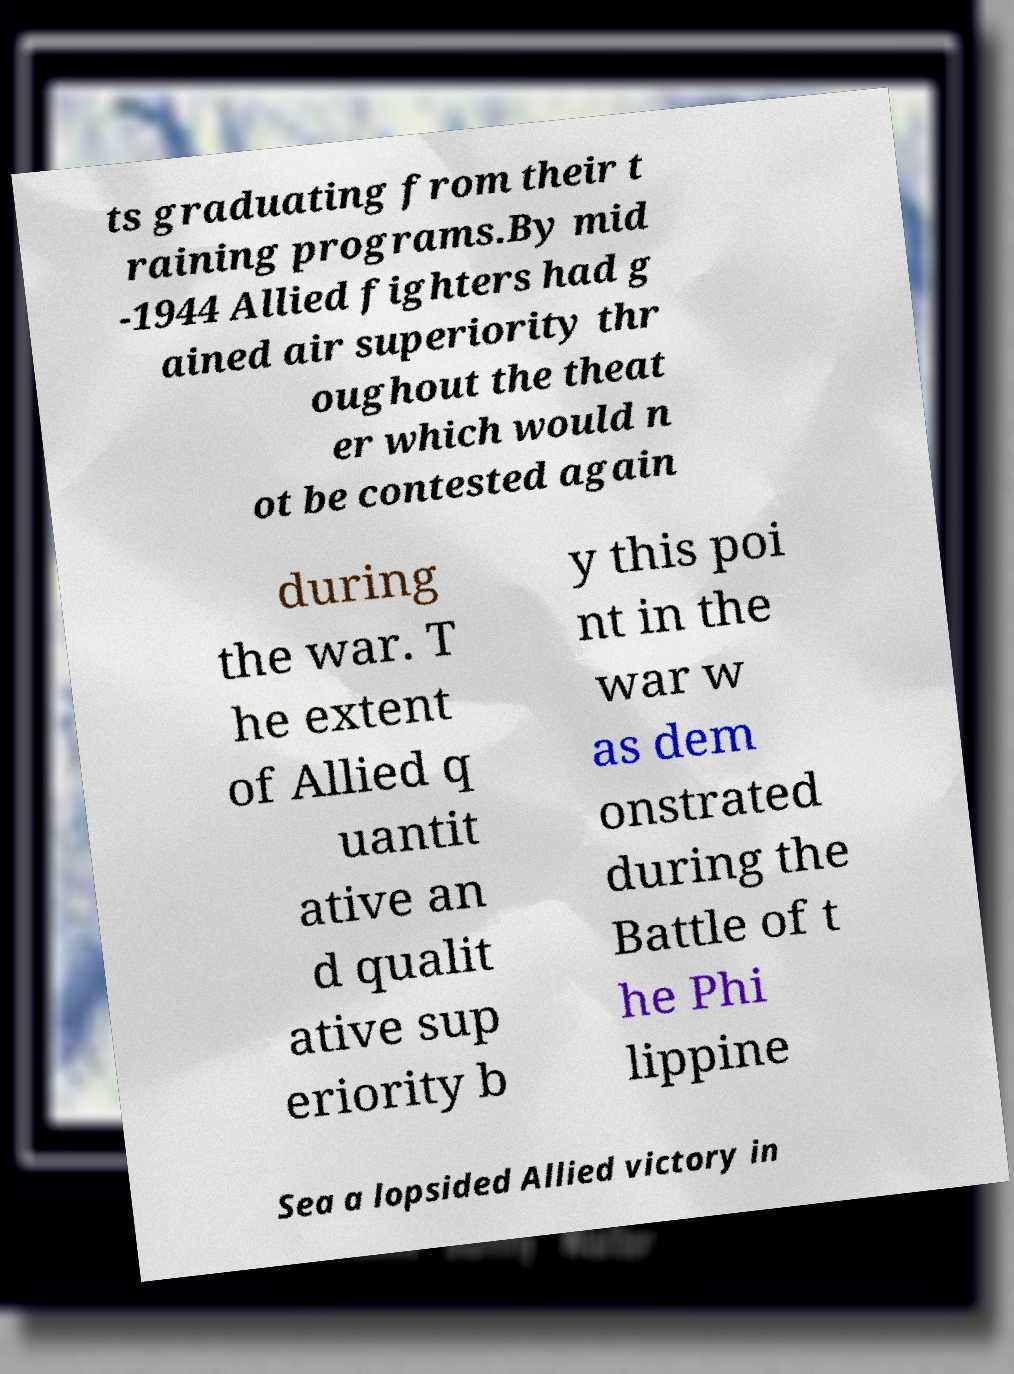Can you read and provide the text displayed in the image?This photo seems to have some interesting text. Can you extract and type it out for me? ts graduating from their t raining programs.By mid -1944 Allied fighters had g ained air superiority thr oughout the theat er which would n ot be contested again during the war. T he extent of Allied q uantit ative an d qualit ative sup eriority b y this poi nt in the war w as dem onstrated during the Battle of t he Phi lippine Sea a lopsided Allied victory in 